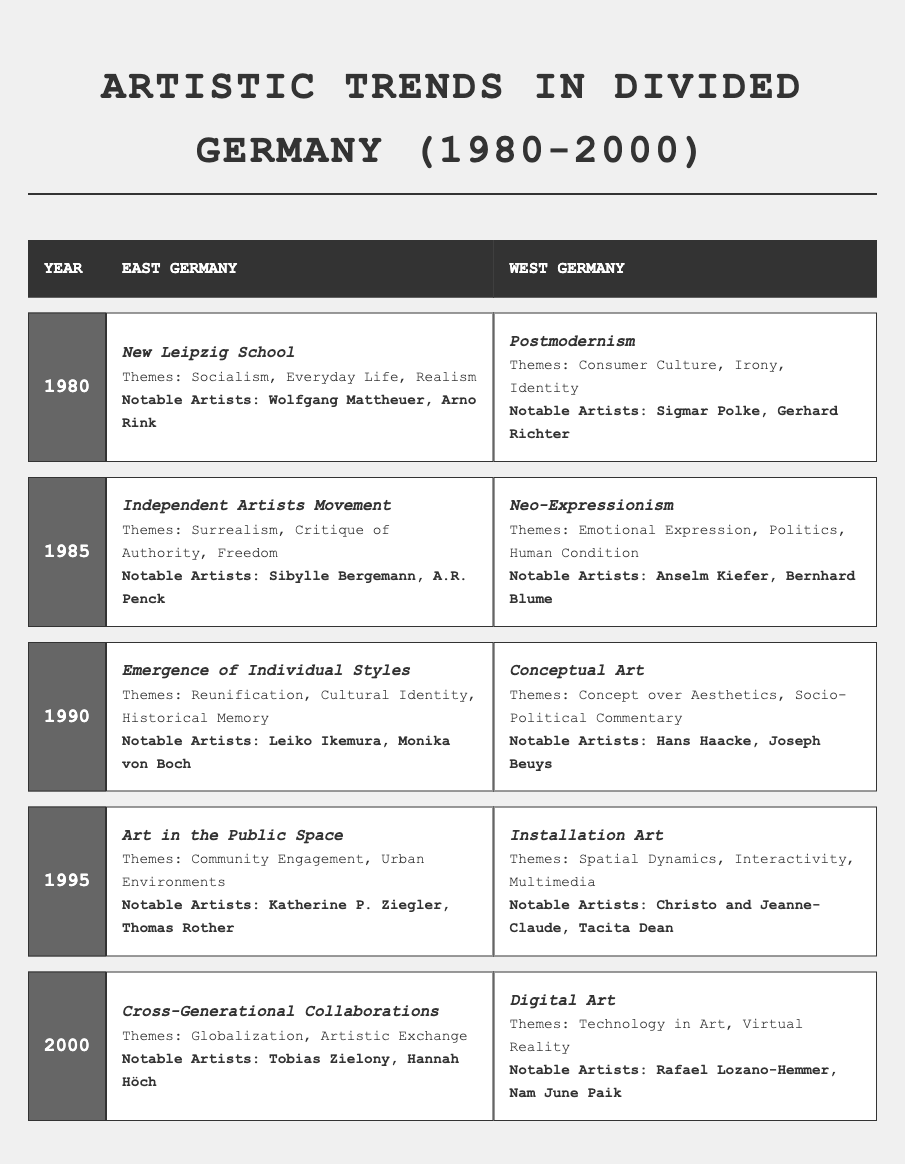What artistic movement was prominent in East Germany in 1985? The table shows that in 1985, the artistic movement in East Germany was the "Independent Artists Movement".
Answer: Independent Artists Movement Which notable West German artists are associated with Neo-Expressionism? In the table, it indicates that Anselm Kiefer and Bernhard Blume are the notable artists associated with Neo-Expressionism in West Germany, specifically in 1985.
Answer: Anselm Kiefer, Bernhard Blume What themes were explored by East German artists in 1990? The table lists the themes explored by East German artists in 1990 as "Reunification", "Cultural Identity", and "Historical Memory".
Answer: Reunification, Cultural Identity, Historical Memory Did East German artists focus on technology in their work by the year 2000? According to the data, East German artists in 2000 focused on "Globalization" and "Artistic Exchange", not directly on technology.
Answer: No What is the difference in artistic movements between East and West Germany in the year 1995? In 1995, East Germany had "Art in the Public Space", while West Germany had "Installation Art". The movements differ in focus on community engagement versus spatial dynamics.
Answer: Art in the Public Space vs. Installation Art How many notable East German artists are listed for the year 1980? The table shows two notable East German artists listed for the year 1980: Wolfgang Mattheuer and Arno Rink.
Answer: Two Which artistic movement transitioned in themes concerning community in both East and West Germany by 1995? Both East Germany (Art in the Public Space) and West Germany (Installation Art) transitioned to themes concerning community engagement, though their approaches differed.
Answer: Art in the Public Space and Installation Art What were the common themes in the artistic movements of East Germany in 1980 and 1985? Both years show a focus on societal issues; in 1980, the themes included "Socialism" and "Everyday Life", while in 1985, themes such as "Surrealism" and "Critique of Authority" pointed to a reflective societal critique.
Answer: Societal issues and critique List the notable artists involved in both East and West Germany by the year 2000. The table shows that by 2000, notable artists in East Germany included Tobias Zielony and Hannah Höch, while West Germany had Rafael Lozano-Hemmer and Nam June Paik.
Answer: Tobias Zielony, Hannah Höch, Rafael Lozano-Hemmer, Nam June Paik Which region showed a stronger inclination towards political themes by 1995? West Germany, with movements like Installation Art emphasizing socio-political commentary and interactivity, displayed a stronger inclination towards political themes compared to East Germany.
Answer: West Germany In what year did East German art begin to emphasize globalization themes? The table indicates that East German art began to emphasize globalization themes in the year 2000, evident in the movement "Cross-Generational Collaborations".
Answer: 2000 